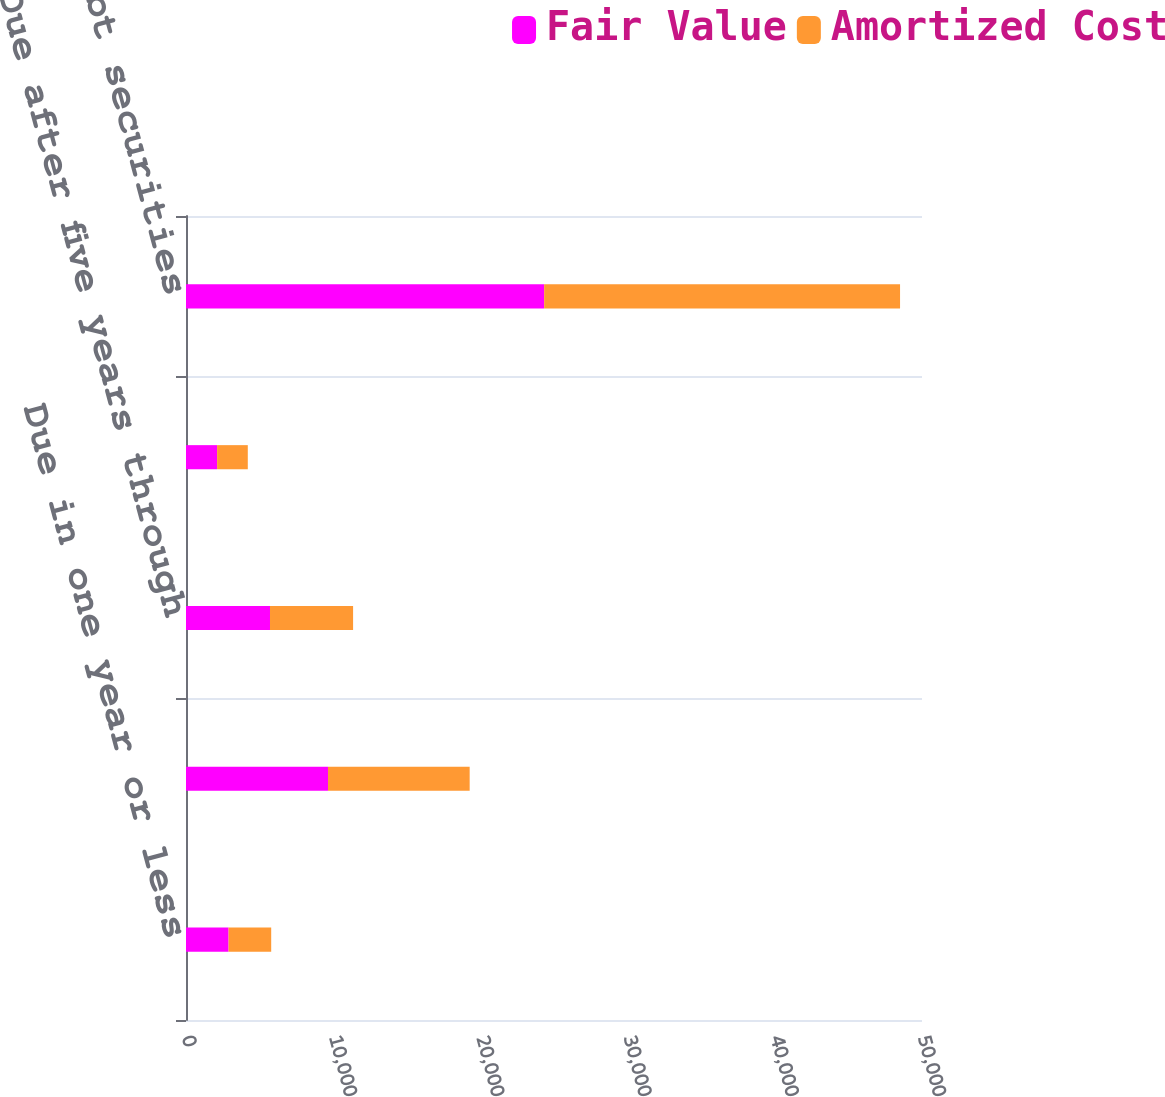Convert chart. <chart><loc_0><loc_0><loc_500><loc_500><stacked_bar_chart><ecel><fcel>Due in one year or less<fcel>Due after one year through<fcel>Due after five years through<fcel>Due after ten years<fcel>Total debt securities<nl><fcel>Fair Value<fcel>2893<fcel>9646<fcel>5706<fcel>2113<fcel>24330<nl><fcel>Amortized Cost<fcel>2895<fcel>9625<fcel>5645<fcel>2085<fcel>24179<nl></chart> 